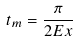Convert formula to latex. <formula><loc_0><loc_0><loc_500><loc_500>t _ { m } = \frac { \pi } { 2 E x }</formula> 